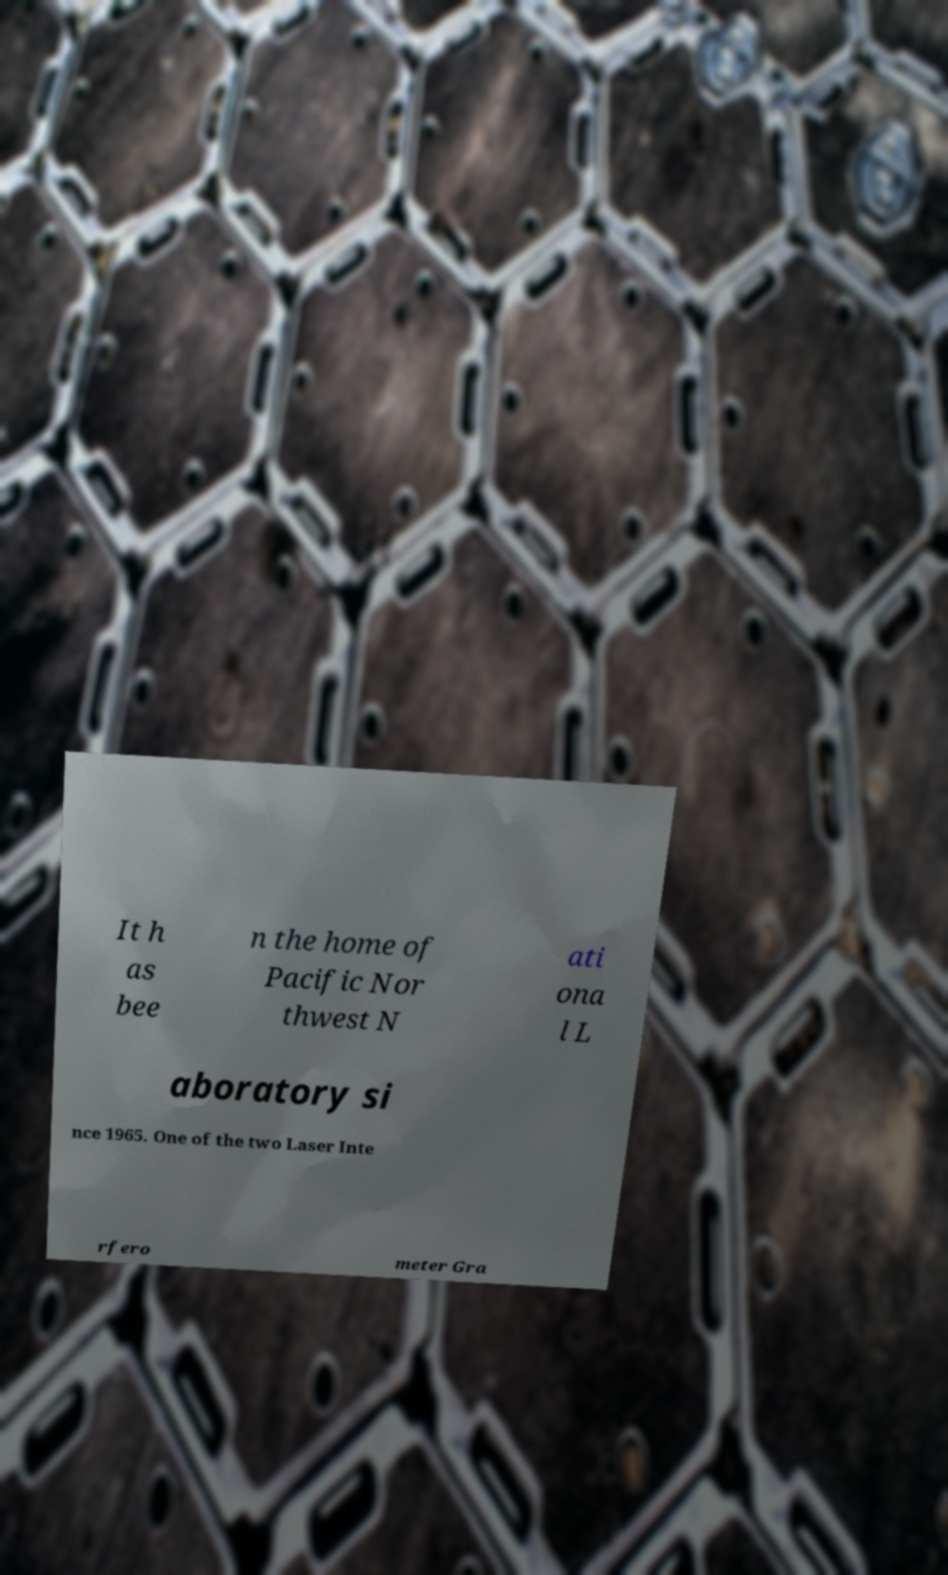Please read and relay the text visible in this image. What does it say? It h as bee n the home of Pacific Nor thwest N ati ona l L aboratory si nce 1965. One of the two Laser Inte rfero meter Gra 